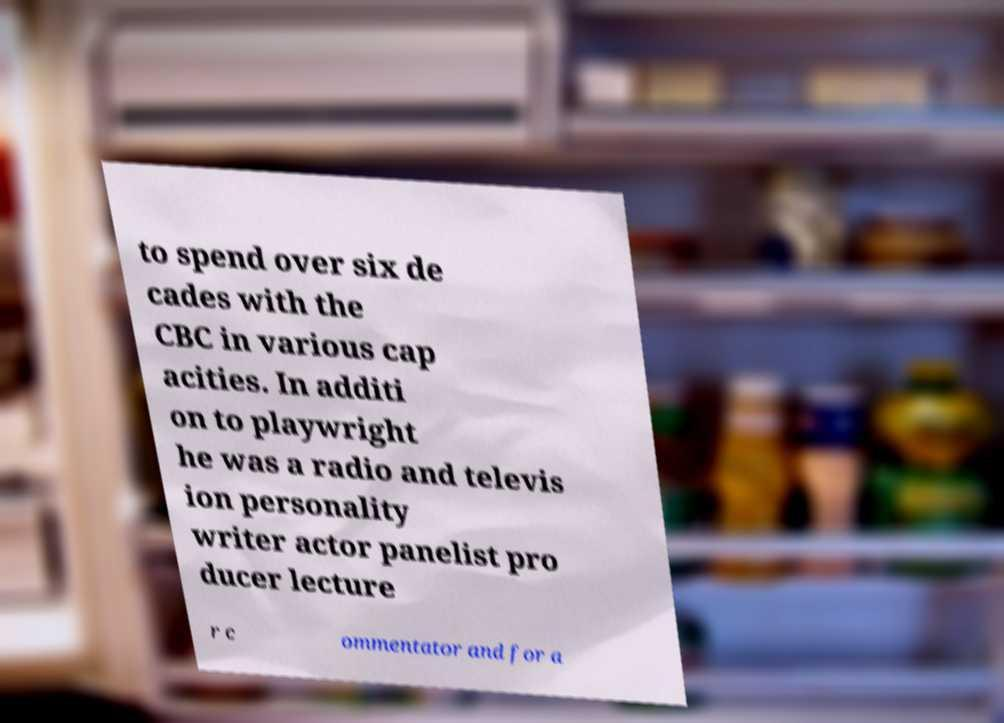There's text embedded in this image that I need extracted. Can you transcribe it verbatim? to spend over six de cades with the CBC in various cap acities. In additi on to playwright he was a radio and televis ion personality writer actor panelist pro ducer lecture r c ommentator and for a 